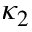Convert formula to latex. <formula><loc_0><loc_0><loc_500><loc_500>\kappa _ { 2 }</formula> 